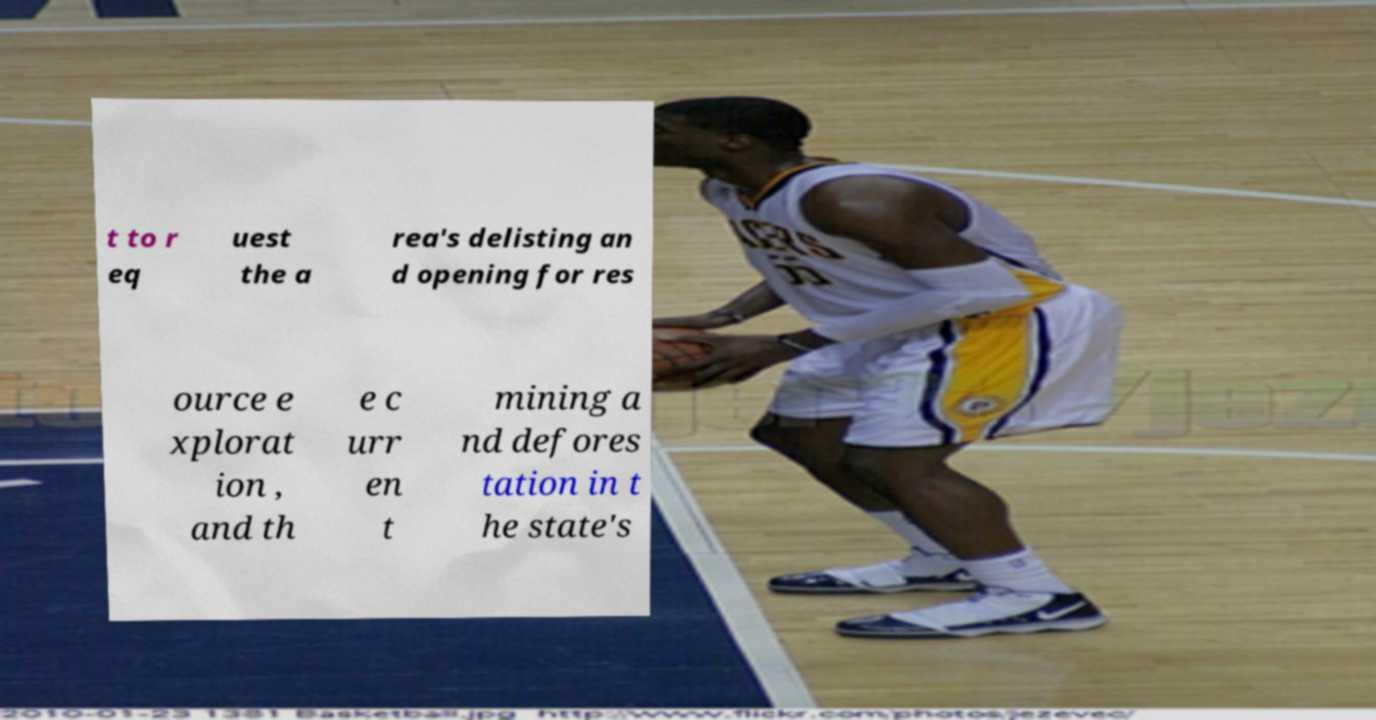What messages or text are displayed in this image? I need them in a readable, typed format. t to r eq uest the a rea's delisting an d opening for res ource e xplorat ion , and th e c urr en t mining a nd defores tation in t he state's 